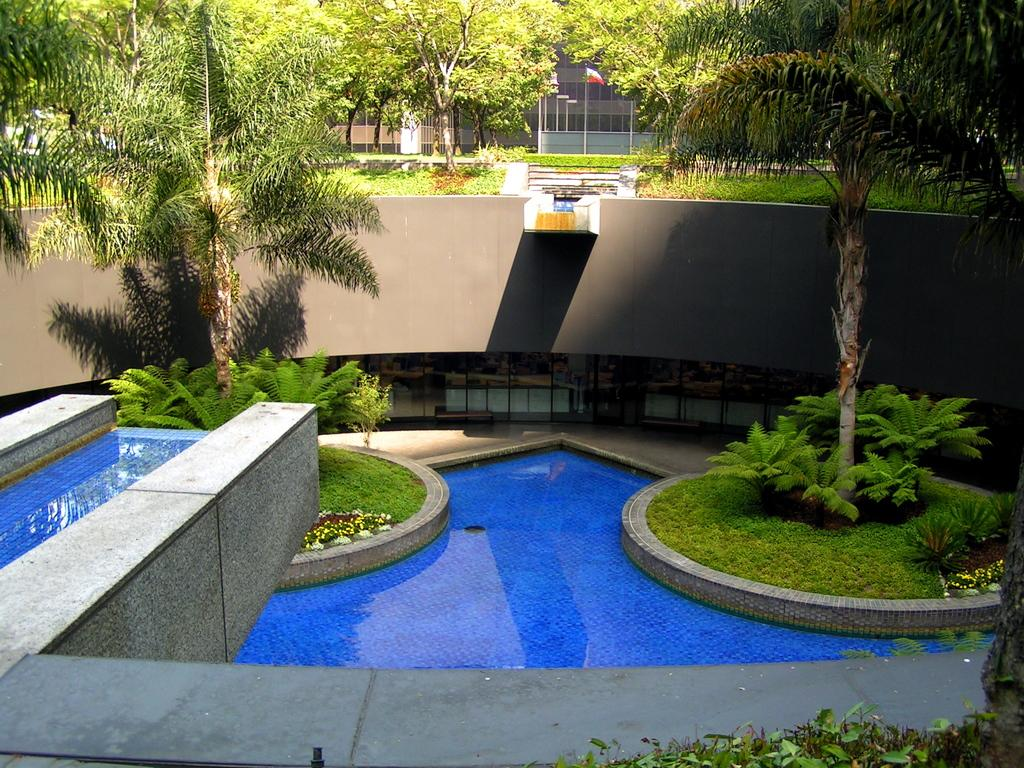What type of structure is visible in the image? There is a building in the image. What natural elements can be seen in the image? There are trees, bushes, plants, and flowers in the image. Are there any architectural features present in the image? Yes, there are stairs in the image. What recreational feature is present in the image? There is a swimming pool in the image. What type of substance is causing the cough in the image? There is no cough or substance present in the image. How does the earthquake affect the building in the image? There is no earthquake present in the image, so its effects cannot be determined. 